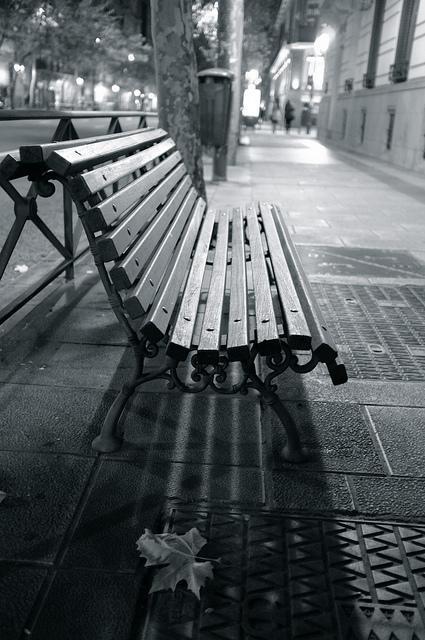In what area is this chair located?
Indicate the correct response by choosing from the four available options to answer the question.
Options: Park, playground, side walk, backyard. Side walk. 